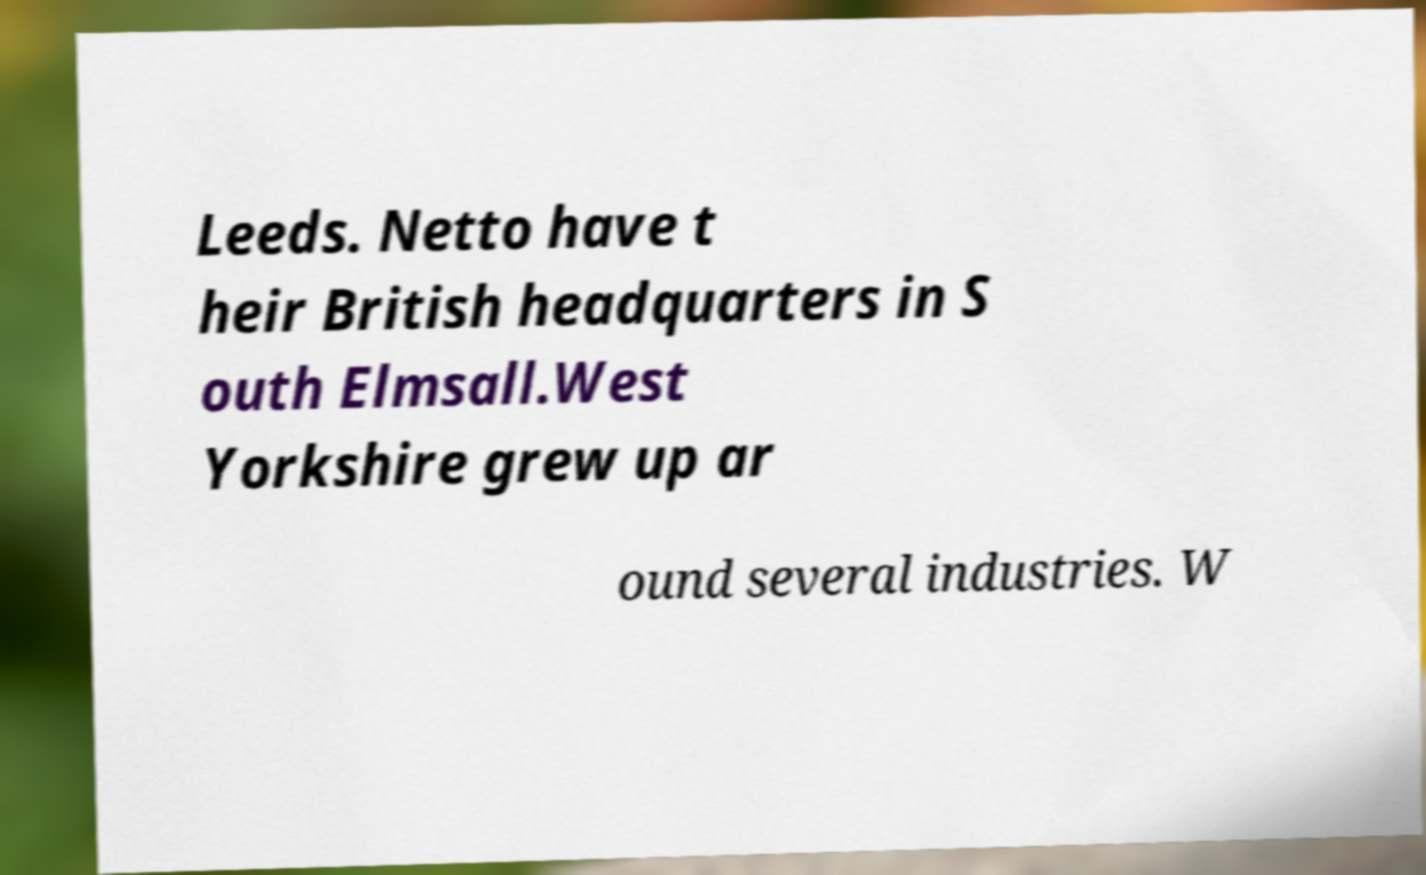Could you assist in decoding the text presented in this image and type it out clearly? Leeds. Netto have t heir British headquarters in S outh Elmsall.West Yorkshire grew up ar ound several industries. W 